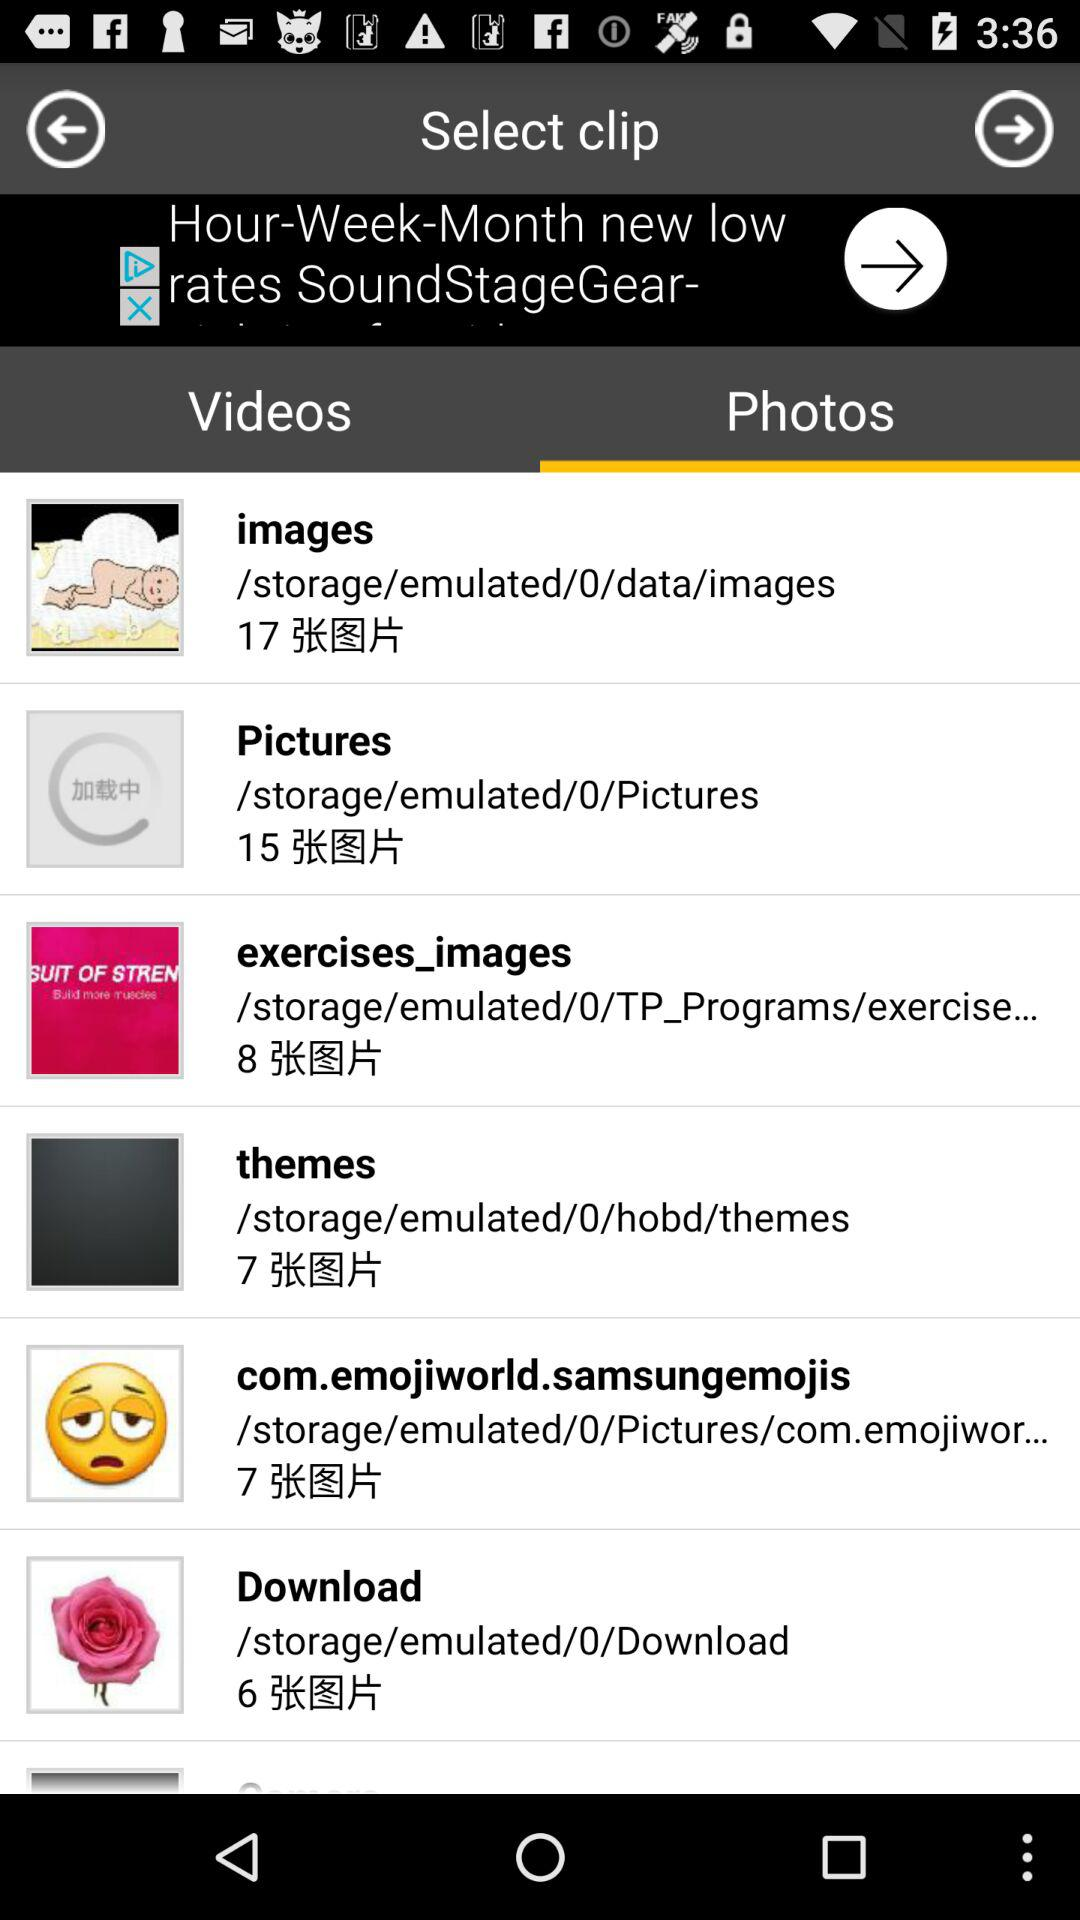Which tab is selected? The selected tab is "Photos". 